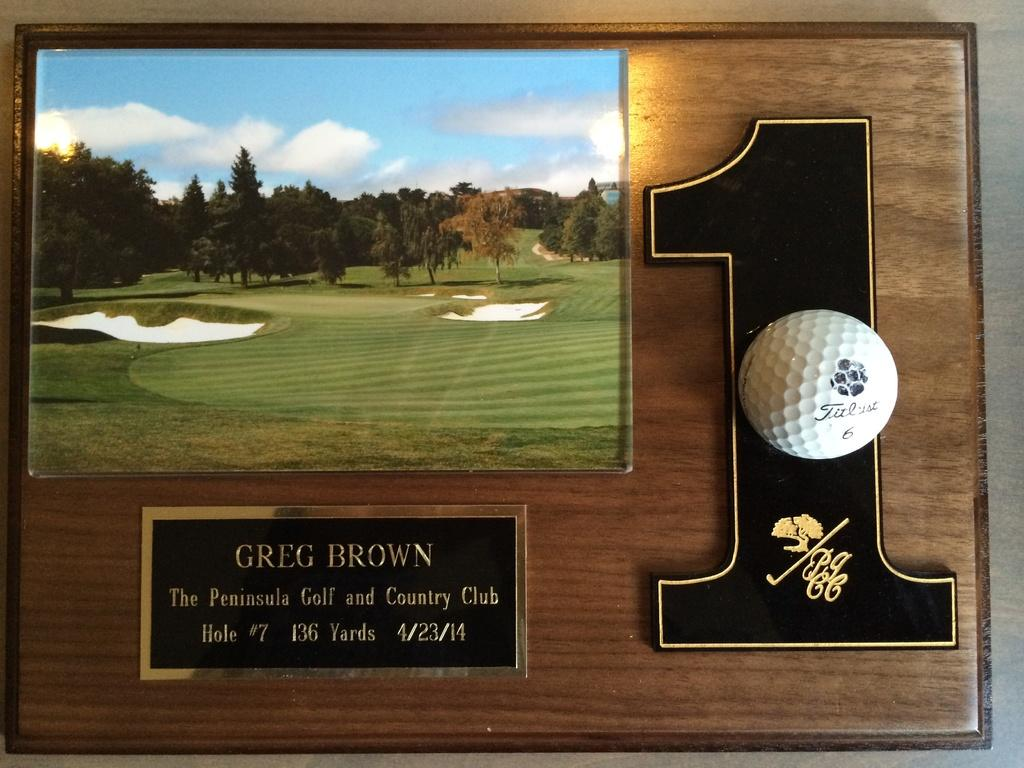<image>
Provide a brief description of the given image. a plaque with the number 1 on it 